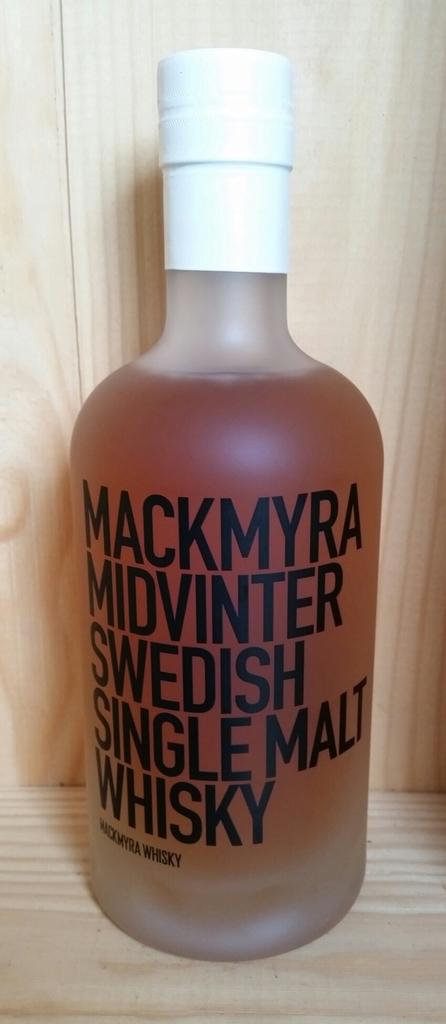What country is this beverage affiliated with?
Your response must be concise. Sweden. How many malt whisky is this?
Give a very brief answer. Single. 